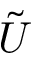<formula> <loc_0><loc_0><loc_500><loc_500>\tilde { U }</formula> 